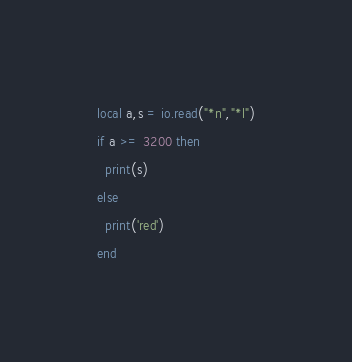<code> <loc_0><loc_0><loc_500><loc_500><_Lua_>local a,s = io.read("*n","*l")
if a >= 3200 then
  print(s)
else 
  print('red')
end</code> 